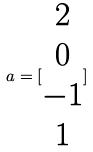Convert formula to latex. <formula><loc_0><loc_0><loc_500><loc_500>a = [ \begin{matrix} 2 \\ 0 \\ - 1 \\ 1 \end{matrix} ]</formula> 